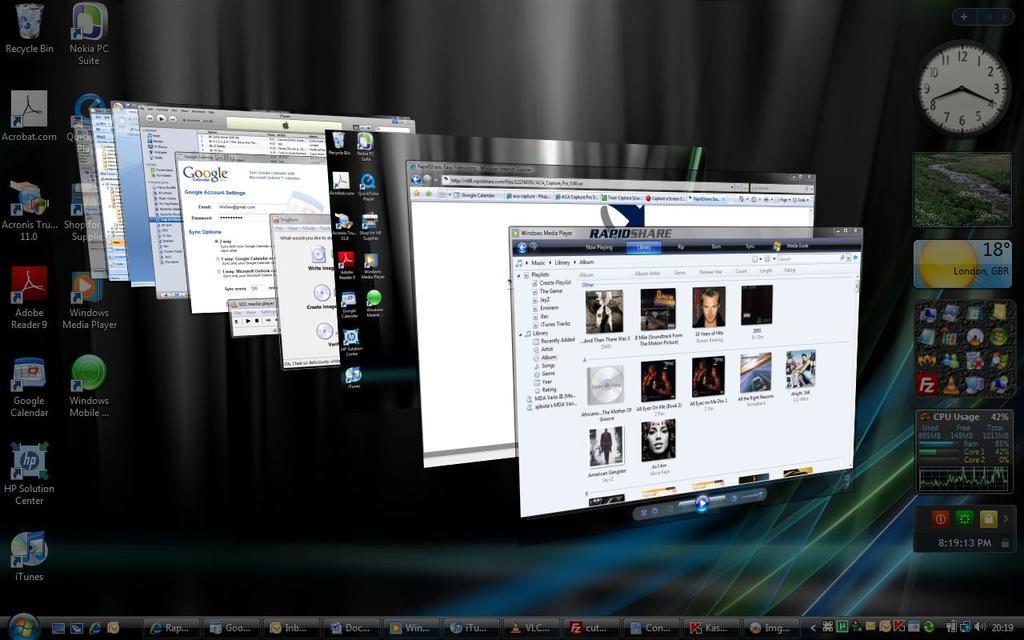What time does the computer show?
Your answer should be compact. 8:20. 